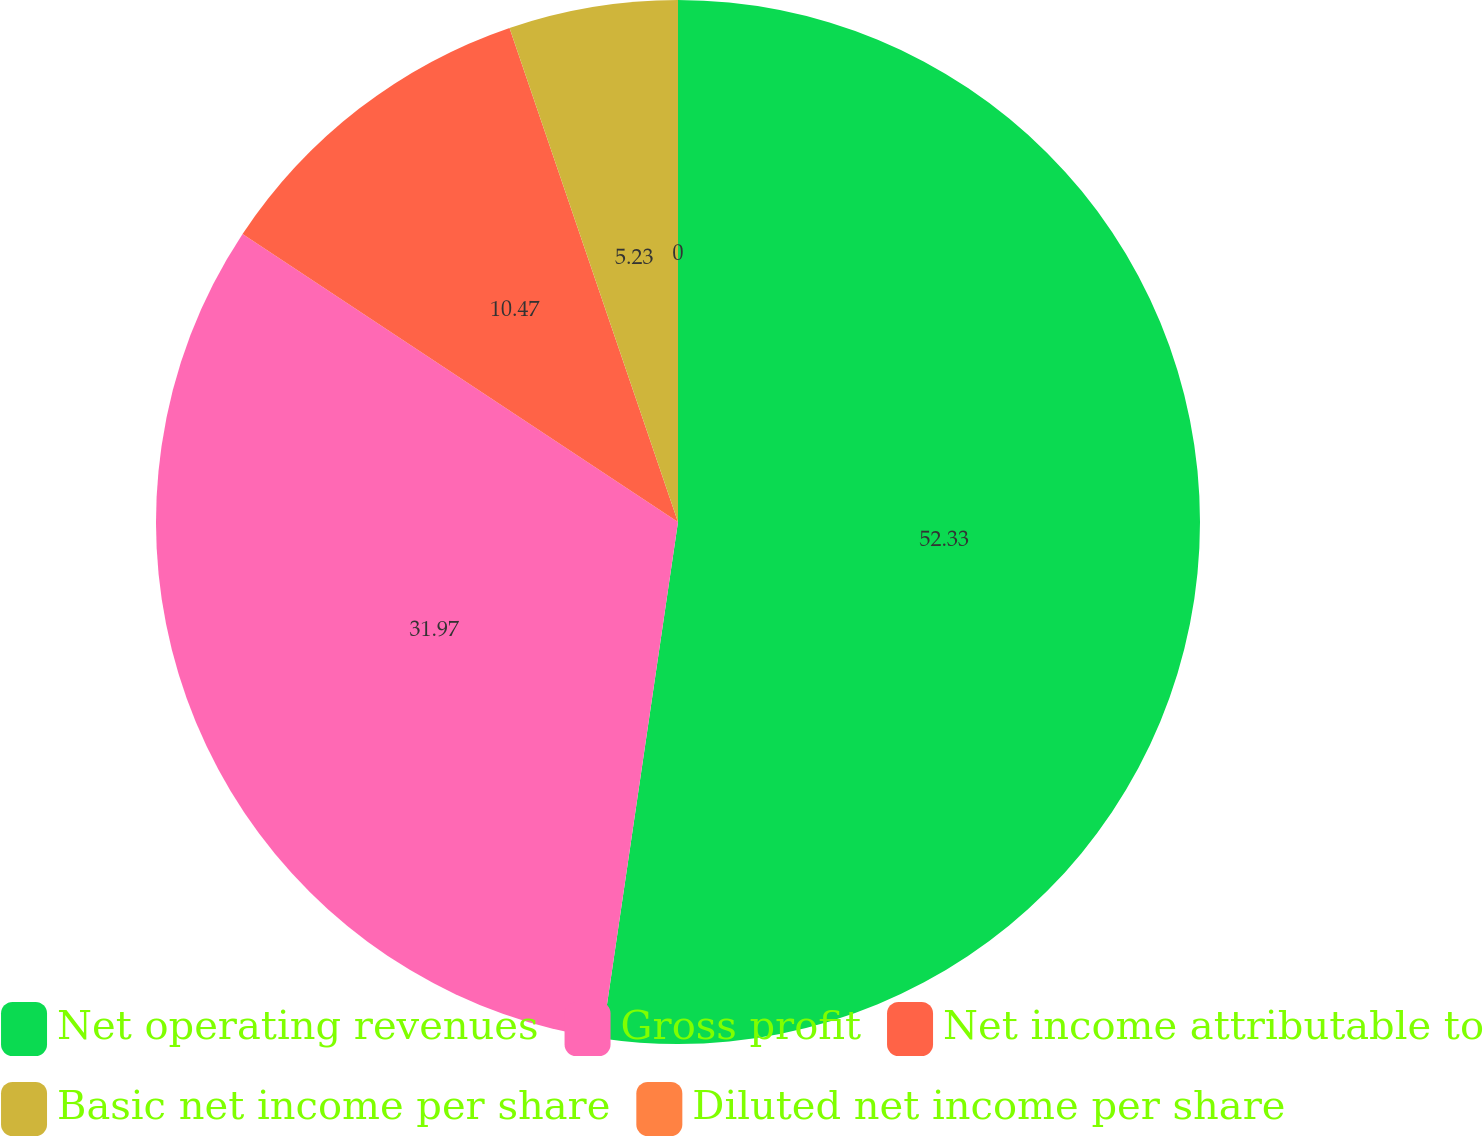Convert chart. <chart><loc_0><loc_0><loc_500><loc_500><pie_chart><fcel>Net operating revenues<fcel>Gross profit<fcel>Net income attributable to<fcel>Basic net income per share<fcel>Diluted net income per share<nl><fcel>52.32%<fcel>31.97%<fcel>10.47%<fcel>5.23%<fcel>0.0%<nl></chart> 